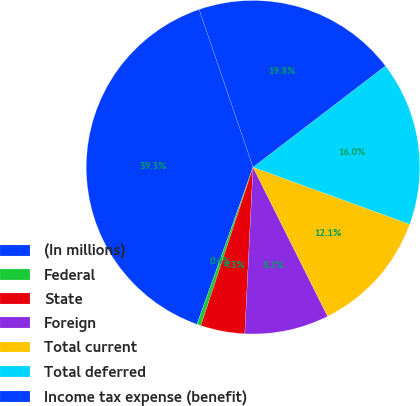Convert chart. <chart><loc_0><loc_0><loc_500><loc_500><pie_chart><fcel>(In millions)<fcel>Federal<fcel>State<fcel>Foreign<fcel>Total current<fcel>Total deferred<fcel>Income tax expense (benefit)<nl><fcel>39.3%<fcel>0.39%<fcel>4.28%<fcel>8.17%<fcel>12.06%<fcel>15.95%<fcel>19.84%<nl></chart> 